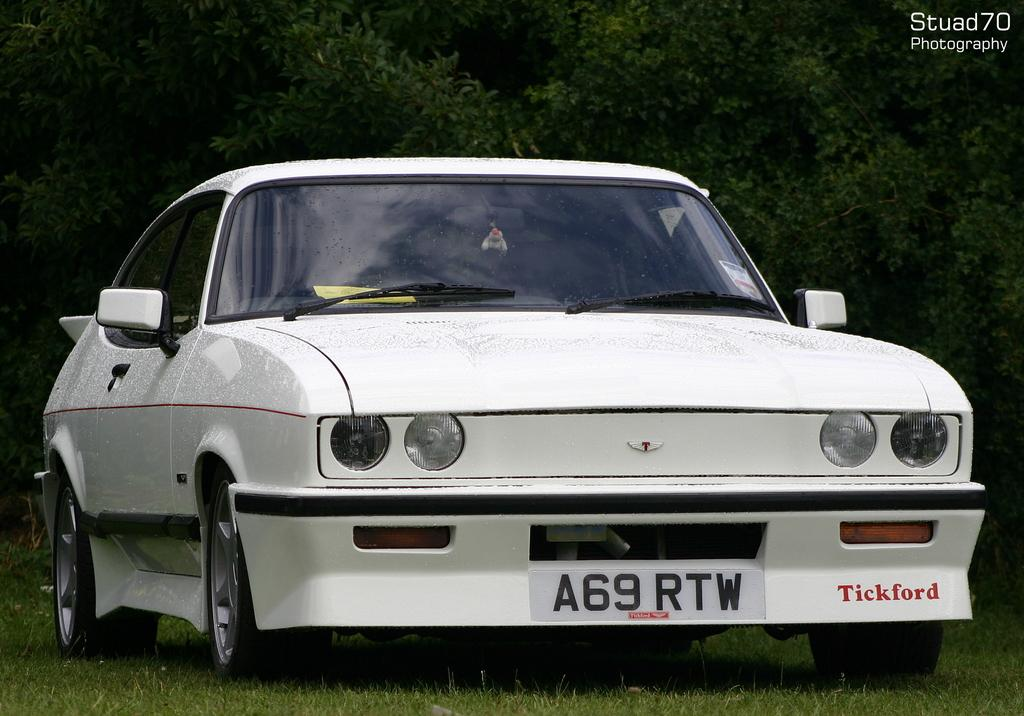What type of vehicle is in the image? There is a white car in the image. Where is the car located? The car is on a grass path. What can be seen in the background of the image? There are trees behind the car. Is there any text or logo overlaid on the image? Yes, the image has a watermark. What type of jar is visible on the grass path next to the car? There is no jar present on the grass path next to the car in the image. Are there any bears visible in the image? No, there are no bears visible in the image. 